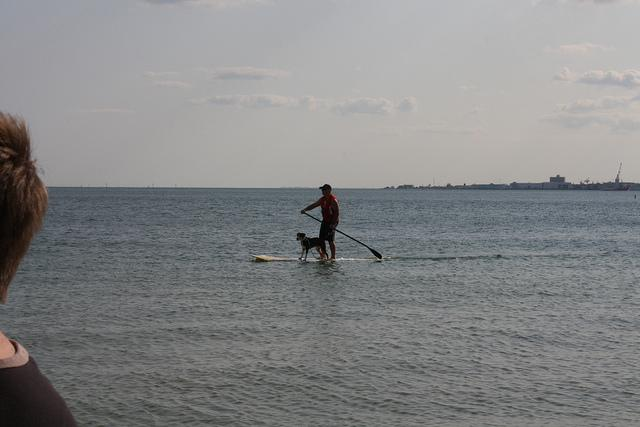What type of vehicle is present in the water? Please explain your reasoning. board. Vehicles without wheels don't work well in the water. 